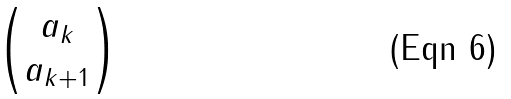<formula> <loc_0><loc_0><loc_500><loc_500>\begin{pmatrix} a _ { k } \\ a _ { k + 1 } \end{pmatrix}</formula> 